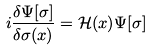Convert formula to latex. <formula><loc_0><loc_0><loc_500><loc_500>i \frac { \delta \Psi [ \sigma ] } { \delta \sigma ( x ) } = \mathcal { H } ( x ) \Psi [ \sigma ]</formula> 